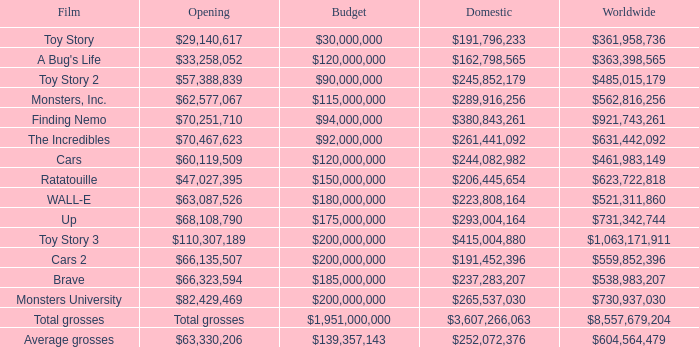For which opening is the international total $559,852,396? $66,135,507. 